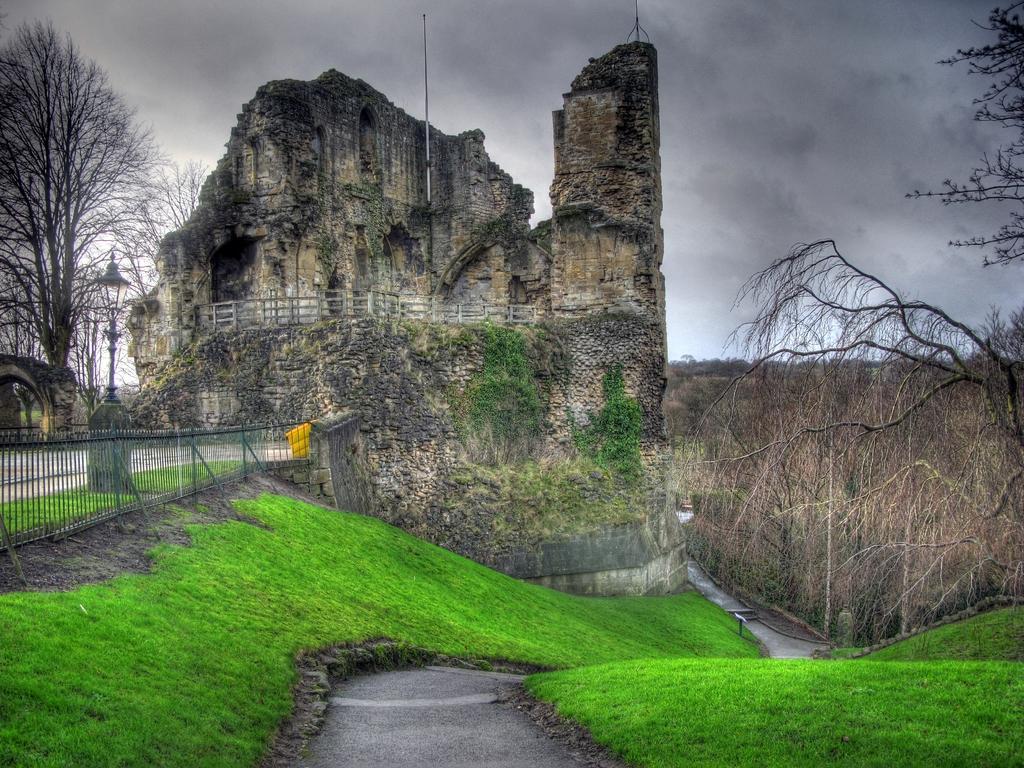Could you give a brief overview of what you see in this image? This image is an edited image. This image is taken outdoors. At the top of the image there is the sky with clouds. At the bottom of the image there is a ground with grass on it. On the right side of the image there are many trees and plants on the ground. On the left side of the image there is a tree. There is a pole with a light. There is a railing. In the middle of the image there is an architecture with walls and there is a railing. 